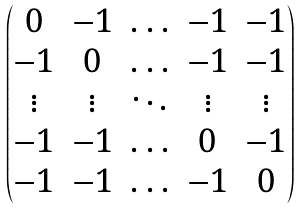Convert formula to latex. <formula><loc_0><loc_0><loc_500><loc_500>\begin{pmatrix} 0 & - 1 & \hdots & - 1 & - 1 \\ - 1 & 0 & \hdots & - 1 & - 1 \\ \vdots & \vdots & \ddots & \vdots & \vdots \\ - 1 & - 1 & \hdots & 0 & - 1 \\ - 1 & - 1 & \hdots & - 1 & 0 \end{pmatrix}</formula> 